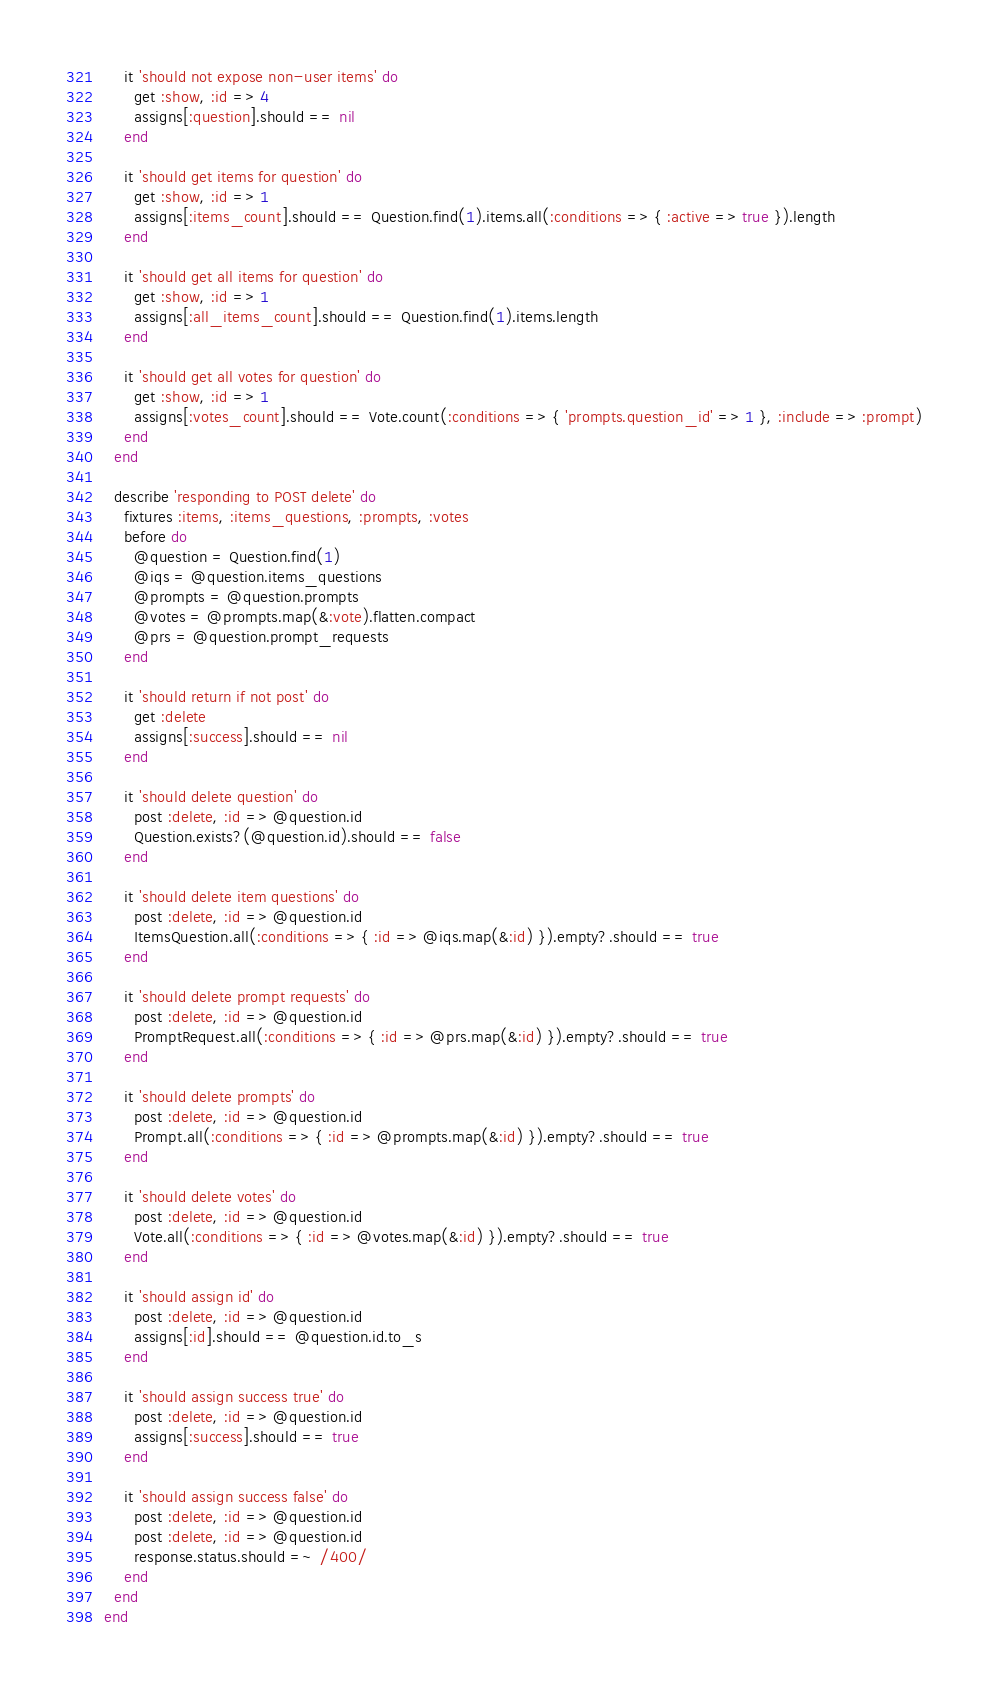Convert code to text. <code><loc_0><loc_0><loc_500><loc_500><_Ruby_>

    it 'should not expose non-user items' do
      get :show, :id => 4
      assigns[:question].should == nil
    end

    it 'should get items for question' do
      get :show, :id => 1
      assigns[:items_count].should == Question.find(1).items.all(:conditions => { :active => true }).length
    end

    it 'should get all items for question' do
      get :show, :id => 1
      assigns[:all_items_count].should == Question.find(1).items.length
    end

    it 'should get all votes for question' do
      get :show, :id => 1
      assigns[:votes_count].should == Vote.count(:conditions => { 'prompts.question_id' => 1 }, :include => :prompt)
    end
  end

  describe 'responding to POST delete' do
    fixtures :items, :items_questions, :prompts, :votes
    before do
      @question = Question.find(1)
      @iqs = @question.items_questions
      @prompts = @question.prompts
      @votes = @prompts.map(&:vote).flatten.compact
      @prs = @question.prompt_requests
    end

    it 'should return if not post' do
      get :delete
      assigns[:success].should == nil
    end

    it 'should delete question' do
      post :delete, :id => @question.id
      Question.exists?(@question.id).should == false
    end

    it 'should delete item questions' do
      post :delete, :id => @question.id
      ItemsQuestion.all(:conditions => { :id => @iqs.map(&:id) }).empty?.should == true
    end

    it 'should delete prompt requests' do
      post :delete, :id => @question.id
      PromptRequest.all(:conditions => { :id => @prs.map(&:id) }).empty?.should == true
    end

    it 'should delete prompts' do
      post :delete, :id => @question.id
      Prompt.all(:conditions => { :id => @prompts.map(&:id) }).empty?.should == true
    end

    it 'should delete votes' do
      post :delete, :id => @question.id
      Vote.all(:conditions => { :id => @votes.map(&:id) }).empty?.should == true
    end

    it 'should assign id' do
      post :delete, :id => @question.id
      assigns[:id].should == @question.id.to_s
    end

    it 'should assign success true' do
      post :delete, :id => @question.id
      assigns[:success].should == true
    end

    it 'should assign success false' do
      post :delete, :id => @question.id
      post :delete, :id => @question.id
      response.status.should =~ /400/
    end
  end
end
</code> 